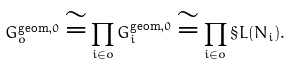Convert formula to latex. <formula><loc_0><loc_0><loc_500><loc_500>G _ { o } ^ { \text {geom} , 0 } \cong \prod _ { i \in o } G _ { i } ^ { \text {geom} , 0 } \cong \prod _ { i \in o } \S L ( N _ { i } ) .</formula> 